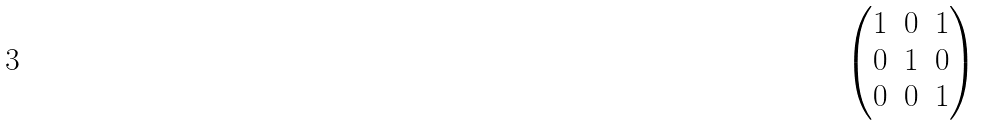<formula> <loc_0><loc_0><loc_500><loc_500>\begin{pmatrix} 1 & 0 & 1 \\ 0 & 1 & 0 \\ 0 & 0 & 1 \\ \end{pmatrix}</formula> 